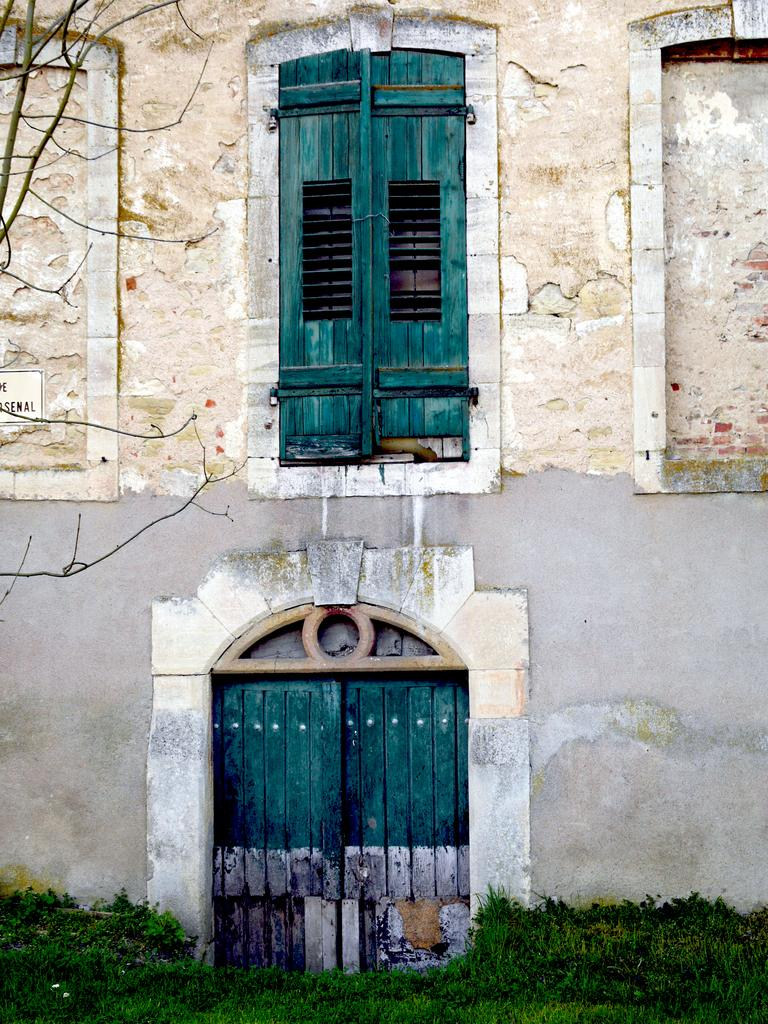What type of structure is visible in the image? There is a building in the image. What feature of the building is mentioned in the facts? The building has two wooden doors. What is the color of the doors? The doors are green in color. What can be seen in front of the building? There is a greenery ground in front of the building. What type of range can be seen in the image? There is no range present in the image. How many cannons are visible in the image? There are no cannons present in the image. 